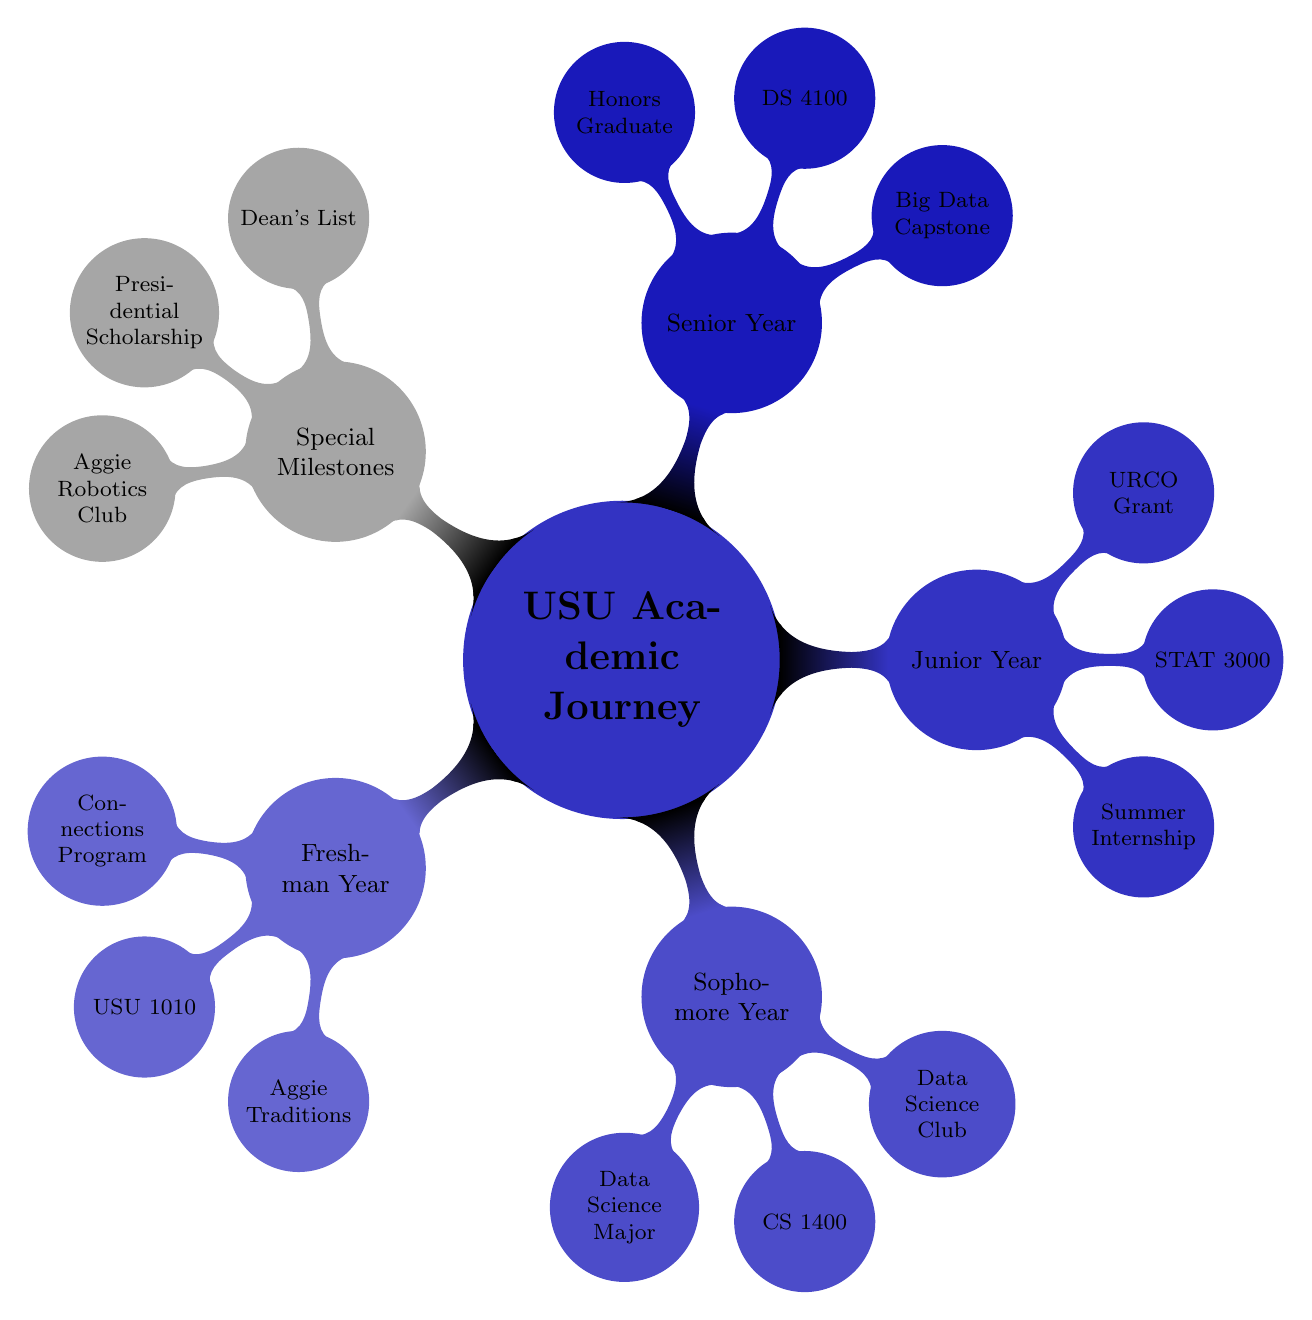What is the key course for Senior Year? The diagram specifies that the key course for Senior Year is "DS 4100 - Data Science Practicum." You can find this information by looking under the "Senior Year" node where it lists the components for that year.
Answer: DS 4100 - Data Science Practicum What achievement did students accomplish in their Senior Year? According to the diagram, the achievement listed for Senior Year is "Graduation with Honors." This information is located under the "Senior Year" node as part of the key milestones for that year.
Answer: Graduation with Honors What extracurricular activity is mentioned in the "Special Milestones"? The diagram mentions "Aggie Robotics Club" as an extracurricular activity in the "Special Milestones" section. To find this, you look under the corresponding node dedicated to special milestones.
Answer: Aggie Robotics Club How many nodes are in the "Sophomore Year"? The "Sophomore Year" section contains three nodes: "Declaring Major in Data Science," "CS 1400," and "Data Science Club." Counting these nodes gives us the total number of components in that year.
Answer: 3 What was a notable event in the Junior Year? The diagram lists "Undergraduate Research and Creative Opportunities (URCO) Grant" as a notable event in the Junior Year. To answer this, you identify the relevant node under the "Junior Year" section of the diagram.
Answer: Undergraduate Research and Creative Opportunities (URCO) Grant What scholarship is featured as a Special Milestone? In the "Special Milestones" section, the scholarship mentioned is the "Utah State Presidential Scholarship." You find this by looking into the special milestones and identifying the nodes listed there.
Answer: Utah State Presidential Scholarship What course is designated as a key course in the Freshman Year? The key course for the Freshman Year is "USU 1010 - University Connections," which is explicitly stated under the "Freshman Year" node in the diagram.
Answer: USU 1010 - University Connections How was the major declared in the Sophomore Year? The diagram indicates that the major was declared by "Declaring Major in Data Science," located under the "Sophomore Year" node. This shows the specific action taken regarding the major during that year.
Answer: Declaring Major in Data Science What internship opportunity is noted in the Junior Year? The internship opportunity listed under the Junior Year is "Summer Internship at Tech Company." This can be determined by checking the relevant node under Junior Year for major activities or milestones that year.
Answer: Summer Internship at Tech Company 